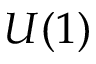<formula> <loc_0><loc_0><loc_500><loc_500>U ( 1 )</formula> 